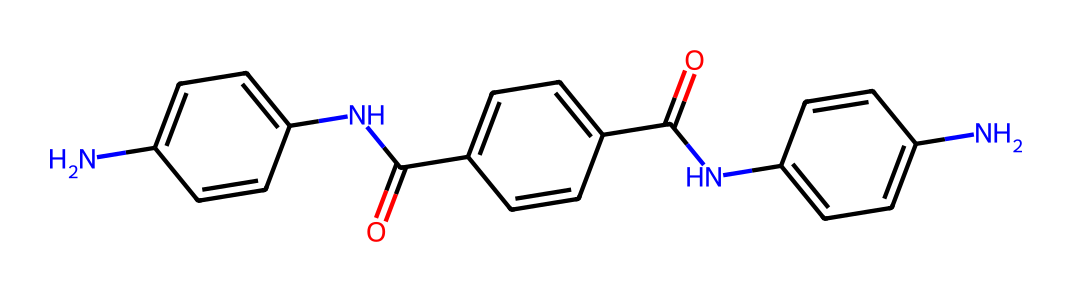What is the total number of carbon atoms in this chemical? By examining the SMILES representation, we can count the carbon atoms. The carbon atoms are represented by the letter 'C'. Counting them in the structure yields a total of 18 carbon atoms.
Answer: 18 How many nitrogen atoms are present in this chemical? The nitrogen atoms are represented by the letter 'N' in the SMILES notation. By carefully counting the 'N' occurrences in the structure, we find there are 3 nitrogen atoms in total.
Answer: 3 What types of functional groups are evident in this chemical? The chemical structure displays amide groups, which are indicated by the presence of 'NC' (nitrogen attached to carbon) followed by a carbonyl group (C=O). Additionally, there are aromatic rings (indicated by 'C=C').
Answer: amide and aromatic Which part of the chemical structure is responsible for high strength? The presence of aromatic rings contributes to the rigidity and tensile strength of aramid fibers. The alternating single and double bonds in the rings enhance stability.
Answer: aromatic rings Is this chemical soluble in water? The presence of multiple amide groups suggests that it has polar characteristics, but the overall structure with large hydrophobic aromatic components indicates that it would be only slightly soluble in water.
Answer: slightly soluble What kind of polymer is represented by this structure? This structure represents an aramid polymer, which is a type of synthetic polymer known for its high strength and thermal stability. The repeating units consist of aromatic amide linkages.
Answer: aramid polymer 